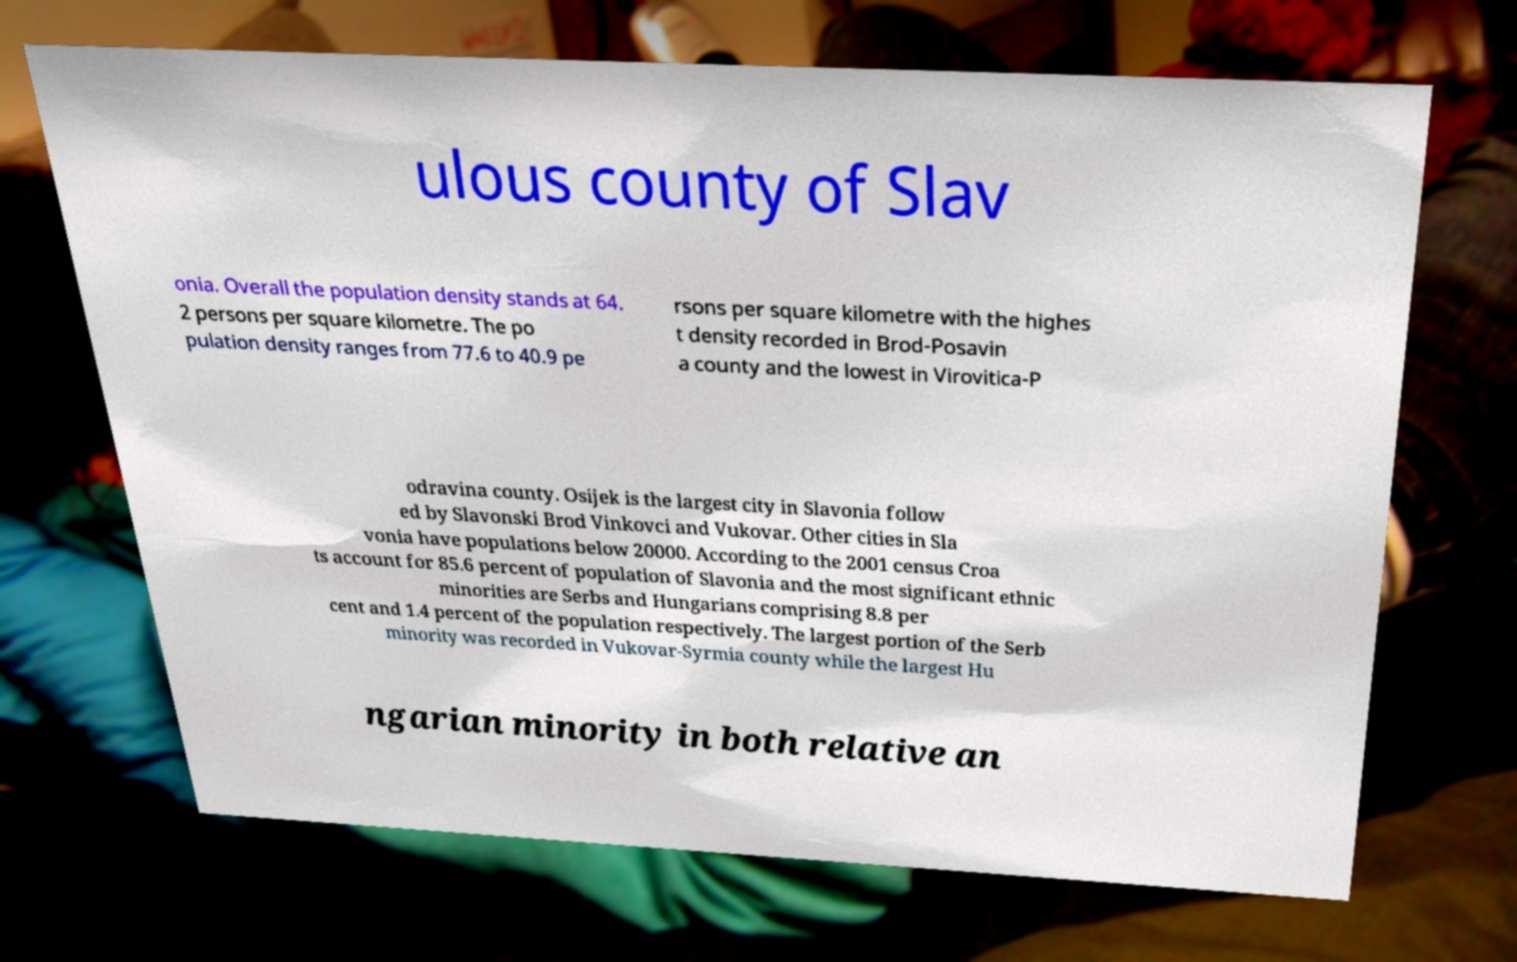Please identify and transcribe the text found in this image. ulous county of Slav onia. Overall the population density stands at 64. 2 persons per square kilometre. The po pulation density ranges from 77.6 to 40.9 pe rsons per square kilometre with the highes t density recorded in Brod-Posavin a county and the lowest in Virovitica-P odravina county. Osijek is the largest city in Slavonia follow ed by Slavonski Brod Vinkovci and Vukovar. Other cities in Sla vonia have populations below 20000. According to the 2001 census Croa ts account for 85.6 percent of population of Slavonia and the most significant ethnic minorities are Serbs and Hungarians comprising 8.8 per cent and 1.4 percent of the population respectively. The largest portion of the Serb minority was recorded in Vukovar-Syrmia county while the largest Hu ngarian minority in both relative an 